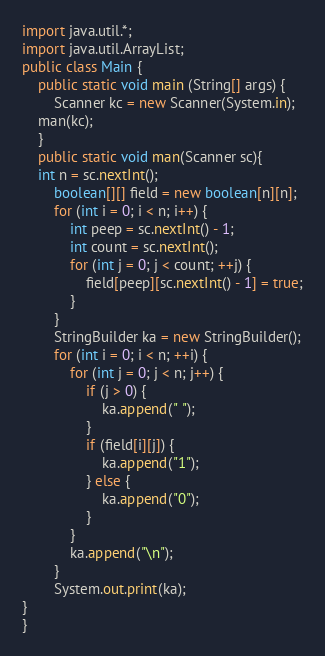<code> <loc_0><loc_0><loc_500><loc_500><_Java_>import java.util.*;
import java.util.ArrayList;
public class Main {
    public static void main (String[] args) {
        Scanner kc = new Scanner(System.in);
    man(kc);
    }
    public static void man(Scanner sc){
    int n = sc.nextInt();
        boolean[][] field = new boolean[n][n];
        for (int i = 0; i < n; i++) {
            int peep = sc.nextInt() - 1;
            int count = sc.nextInt();
            for (int j = 0; j < count; ++j) {
                field[peep][sc.nextInt() - 1] = true;
            }
        }
        StringBuilder ka = new StringBuilder();
        for (int i = 0; i < n; ++i) {
            for (int j = 0; j < n; j++) {
                if (j > 0) {
                    ka.append(" ");
                }
                if (field[i][j]) {
                    ka.append("1");
                } else {
                    ka.append("0");
                }
            }
            ka.append("\n");
        }
        System.out.print(ka);
}
}
</code> 